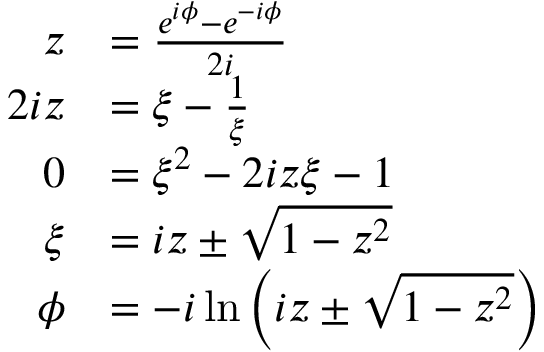Convert formula to latex. <formula><loc_0><loc_0><loc_500><loc_500>{ \begin{array} { r l } { z } & { = { \frac { e ^ { i \phi } - e ^ { - i \phi } } { 2 i } } } \\ { 2 i z } & { = \xi - { \frac { 1 } { \xi } } } \\ { 0 } & { = \xi ^ { 2 } - 2 i z \xi - 1 } \\ { \xi } & { = i z \pm { \sqrt { 1 - z ^ { 2 } } } } \\ { \phi } & { = - i \ln \left ( i z \pm { \sqrt { 1 - z ^ { 2 } } } \right ) } \end{array} }</formula> 